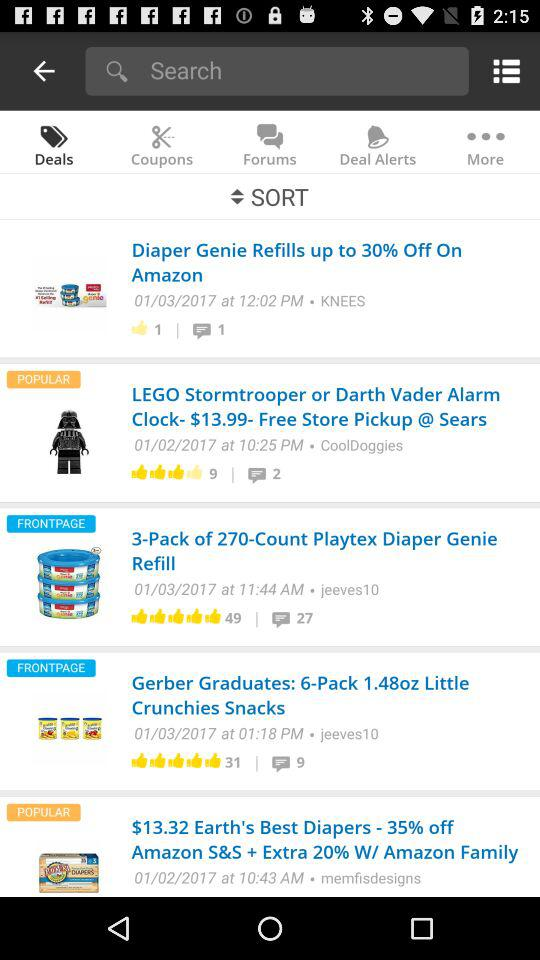What is the price of "Death Vader Alarm Clock"? The price is $13.99. 